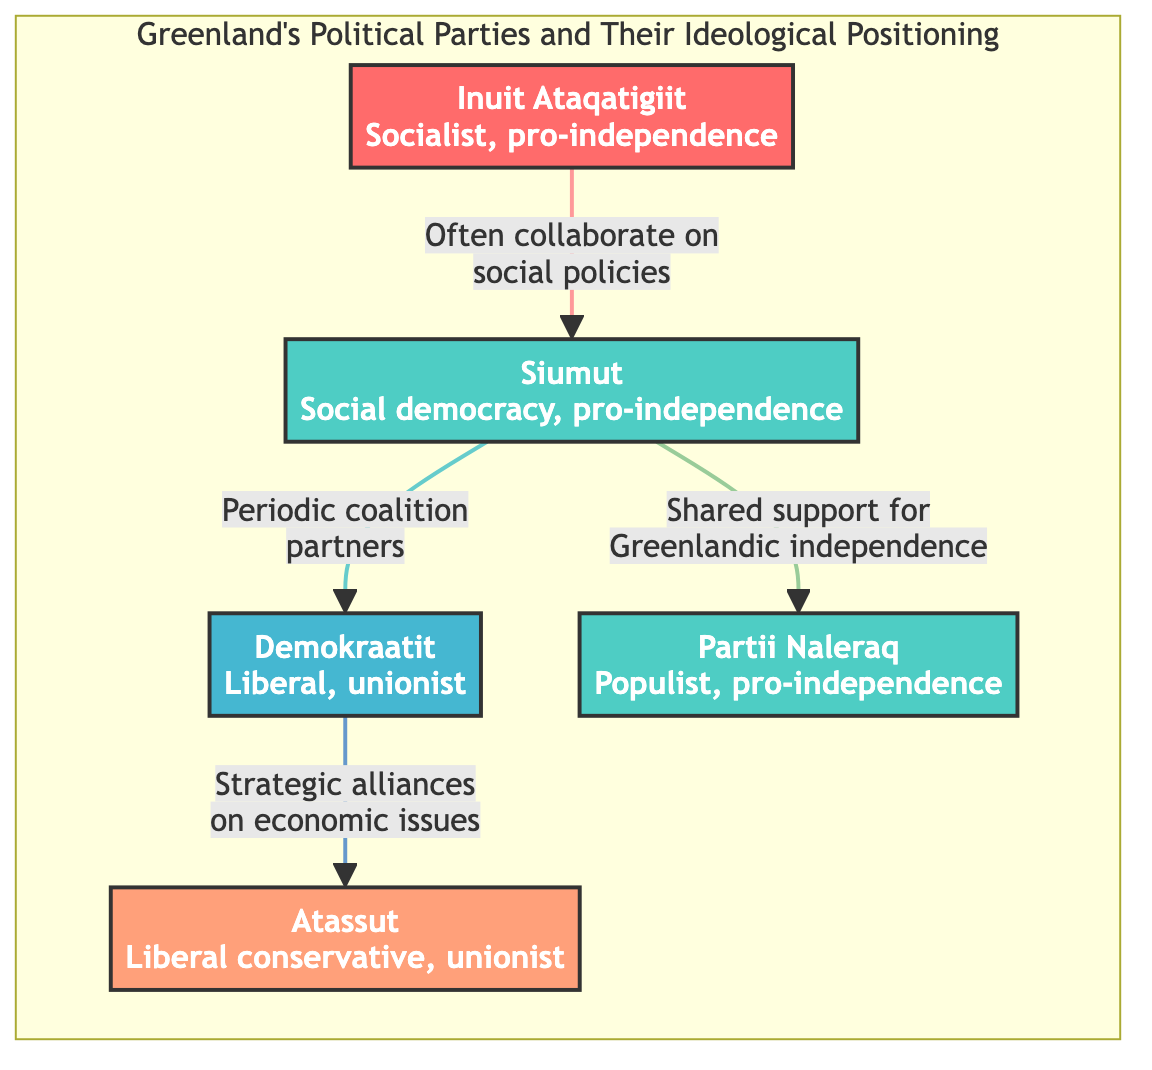What is the ideological positioning of Inuit Ataqatigiit? Inuit Ataqatigiit is labeled as "Socialist, pro-independence" in the diagram, which places it on the left side of the ideological spectrum.
Answer: Socialist, pro-independence How many political parties are listed in the diagram? By counting the nodes in the diagram, we can see there are five political parties represented.
Answer: Five What type of alliances does Siumut have with Demokraatit? The diagram states that Siumut has "Periodic coalition partners" with Demokraatit, indicating a collaborative relationship between the two parties.
Answer: Periodic coalition partners Which political party is categorized as right wing? Atassut is described as "Liberal conservative, unionist" and is positioned on the right side of the spectrum, identifying it as right wing.
Answer: Atassut Which two parties often collaborate on social policies? The diagram indicates that Inuit Ataqatigiit and Siumut often collaborate on social policies, highlighting their cooperative efforts.
Answer: Inuit Ataqatigiit, Siumut What is the relationship between Siumut and Partii Naleraq? The diagram shows that Siumut has shared support for Greenlandic independence with Partii Naleraq, indicating a common goal between these parties.
Answer: Shared support for Greenlandic independence How many edges are shown in the diagram? By counting the connections (edges) between the nodes, we see there are four distinct edges representing the relationships between the parties.
Answer: Four What party is described as populist? The diagram labels Partii Naleraq as "Populist, pro-independence," which directly answers the question about populism.
Answer: Partii Naleraq What parties are identified as unionist? Both Demokraatit and Atassut are designated as unionist in the diagram, indicating their support for maintaining a union.
Answer: Demokraatit, Atassut 